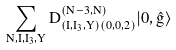Convert formula to latex. <formula><loc_0><loc_0><loc_500><loc_500>\sum _ { N , I , I _ { 3 } , Y } D ^ { ( N - 3 , N ) } _ { ( I , I _ { 3 } , Y ) ( 0 , 0 , 2 ) } | 0 , \hat { g } \rangle</formula> 